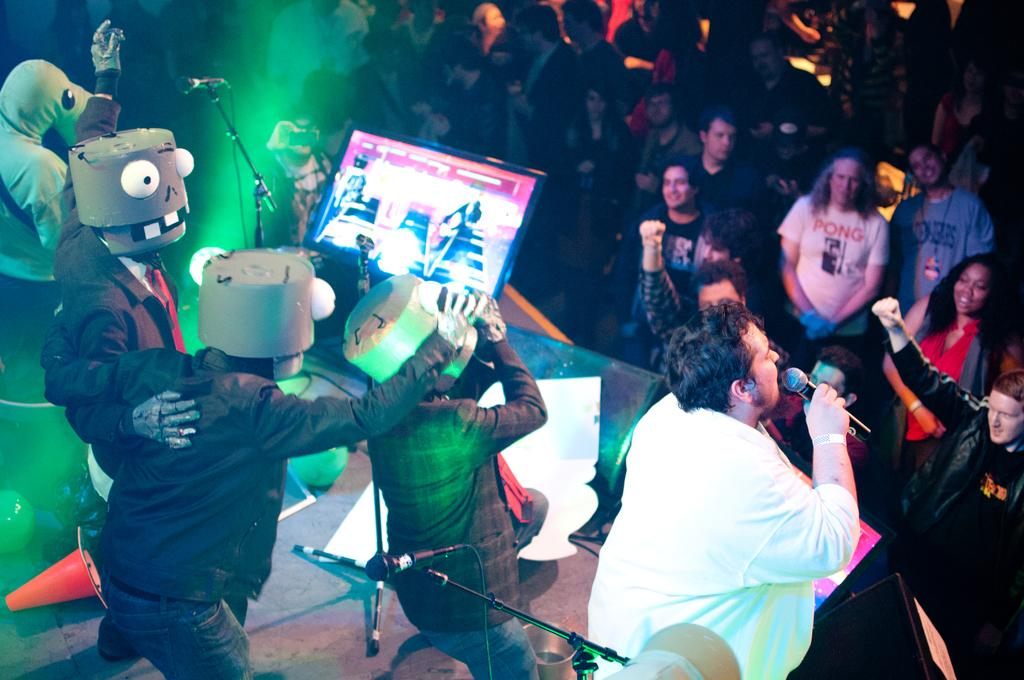What is happening on the floor in the image? There is a crowd on the floor in the image. What objects are related to music in the image? Musical instruments, microphones, and monitors are present in the image. What type of lighting is used in the image? Focus lights are present in the image. Where are the people in the image located? There is a group of people on a stage in the image. Can you describe the lighting conditions in the image? The image may have been taken during the night. What type of paint is being used by the snake in the image? There is no snake or paint present in the image. How much milk is being poured into the microphone in the image? There is no milk or pouring action in the image; microphones are present for amplifying sound. 